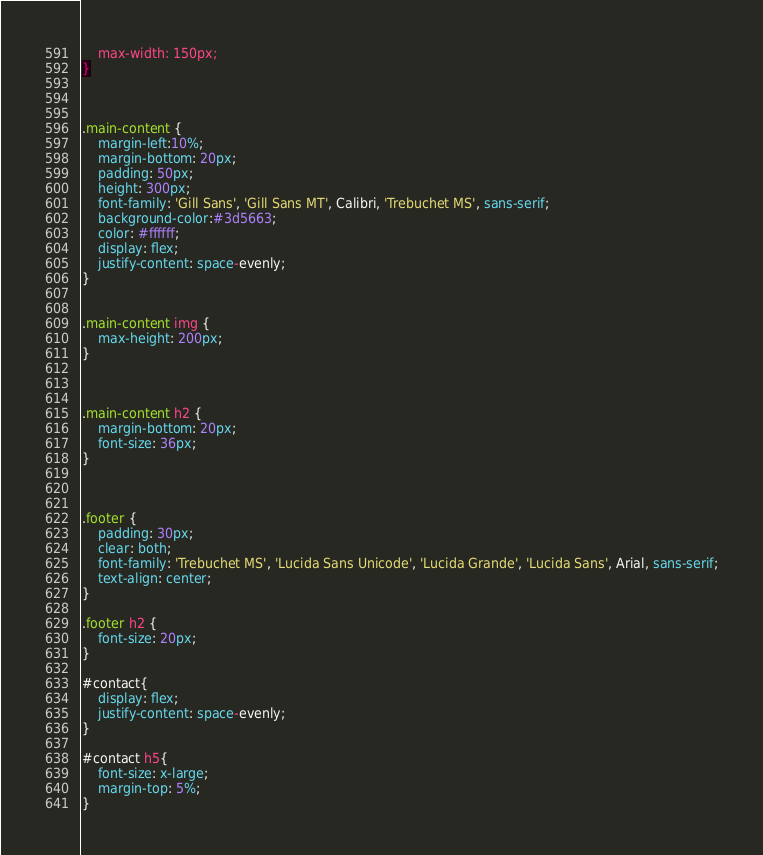<code> <loc_0><loc_0><loc_500><loc_500><_CSS_>    max-width: 150px;
}



.main-content {
    margin-left:10%;
    margin-bottom: 20px;
    padding: 50px;
    height: 300px;
    font-family: 'Gill Sans', 'Gill Sans MT', Calibri, 'Trebuchet MS', sans-serif;
    background-color:#3d5663;
    color: #ffffff;
    display: flex;
    justify-content: space-evenly;
}


.main-content img {
    max-height: 200px;
}



.main-content h2 {
    margin-bottom: 20px;
    font-size: 36px;
}



.footer {
    padding: 30px;
    clear: both;
    font-family: 'Trebuchet MS', 'Lucida Sans Unicode', 'Lucida Grande', 'Lucida Sans', Arial, sans-serif;
    text-align: center;
}

.footer h2 {
    font-size: 20px;
}

#contact{
    display: flex;
    justify-content: space-evenly;
}

#contact h5{
    font-size: x-large;
    margin-top: 5%;
}</code> 